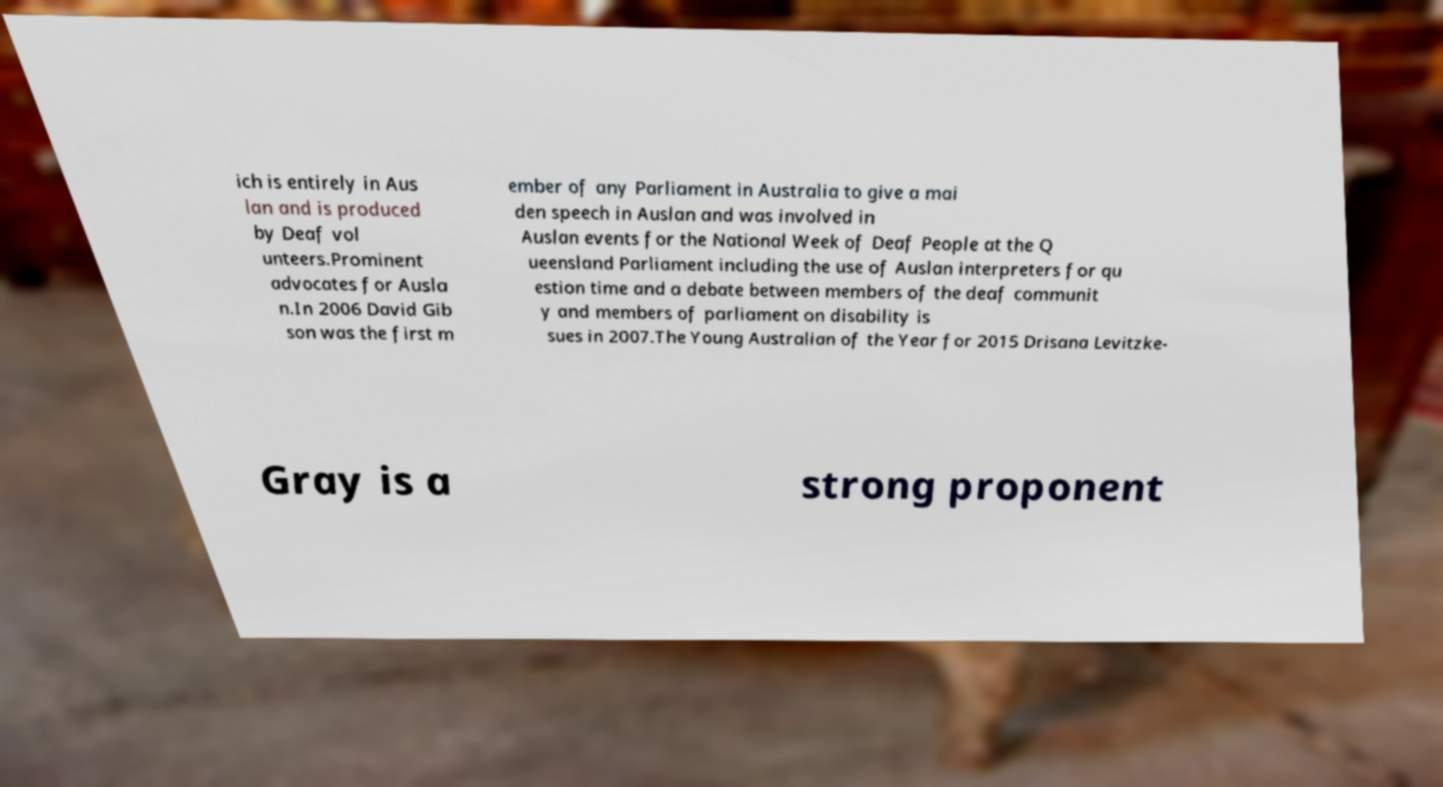For documentation purposes, I need the text within this image transcribed. Could you provide that? ich is entirely in Aus lan and is produced by Deaf vol unteers.Prominent advocates for Ausla n.In 2006 David Gib son was the first m ember of any Parliament in Australia to give a mai den speech in Auslan and was involved in Auslan events for the National Week of Deaf People at the Q ueensland Parliament including the use of Auslan interpreters for qu estion time and a debate between members of the deaf communit y and members of parliament on disability is sues in 2007.The Young Australian of the Year for 2015 Drisana Levitzke- Gray is a strong proponent 